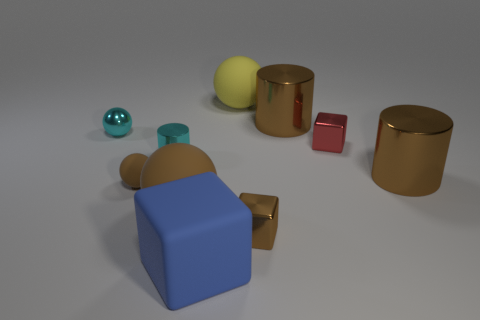Subtract all blue cylinders. How many brown spheres are left? 2 Subtract all small metal cylinders. How many cylinders are left? 2 Subtract all cyan balls. How many balls are left? 3 Subtract 1 cylinders. How many cylinders are left? 2 Subtract all balls. How many objects are left? 6 Add 2 large rubber cubes. How many large rubber cubes exist? 3 Subtract 0 cyan cubes. How many objects are left? 10 Subtract all green cylinders. Subtract all blue blocks. How many cylinders are left? 3 Subtract all large brown cylinders. Subtract all balls. How many objects are left? 4 Add 5 large yellow matte balls. How many large yellow matte balls are left? 6 